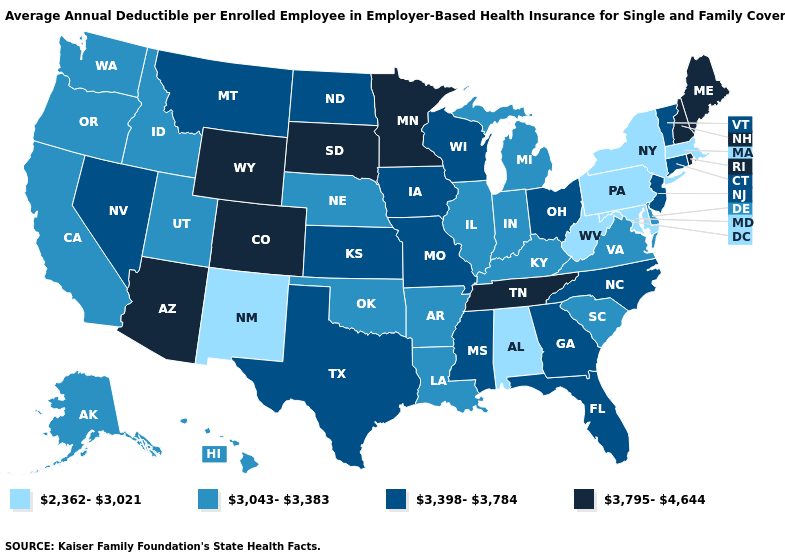What is the value of New York?
Write a very short answer. 2,362-3,021. Does Washington have the same value as Missouri?
Write a very short answer. No. Does Utah have the highest value in the USA?
Keep it brief. No. Among the states that border Connecticut , does Rhode Island have the lowest value?
Concise answer only. No. Does Louisiana have the same value as Tennessee?
Write a very short answer. No. Among the states that border Vermont , which have the highest value?
Short answer required. New Hampshire. Name the states that have a value in the range 3,043-3,383?
Answer briefly. Alaska, Arkansas, California, Delaware, Hawaii, Idaho, Illinois, Indiana, Kentucky, Louisiana, Michigan, Nebraska, Oklahoma, Oregon, South Carolina, Utah, Virginia, Washington. Name the states that have a value in the range 3,043-3,383?
Quick response, please. Alaska, Arkansas, California, Delaware, Hawaii, Idaho, Illinois, Indiana, Kentucky, Louisiana, Michigan, Nebraska, Oklahoma, Oregon, South Carolina, Utah, Virginia, Washington. Name the states that have a value in the range 3,398-3,784?
Keep it brief. Connecticut, Florida, Georgia, Iowa, Kansas, Mississippi, Missouri, Montana, Nevada, New Jersey, North Carolina, North Dakota, Ohio, Texas, Vermont, Wisconsin. What is the value of New Hampshire?
Short answer required. 3,795-4,644. How many symbols are there in the legend?
Give a very brief answer. 4. What is the value of Hawaii?
Give a very brief answer. 3,043-3,383. What is the highest value in the USA?
Keep it brief. 3,795-4,644. What is the value of Nevada?
Short answer required. 3,398-3,784. What is the highest value in states that border North Dakota?
Write a very short answer. 3,795-4,644. 